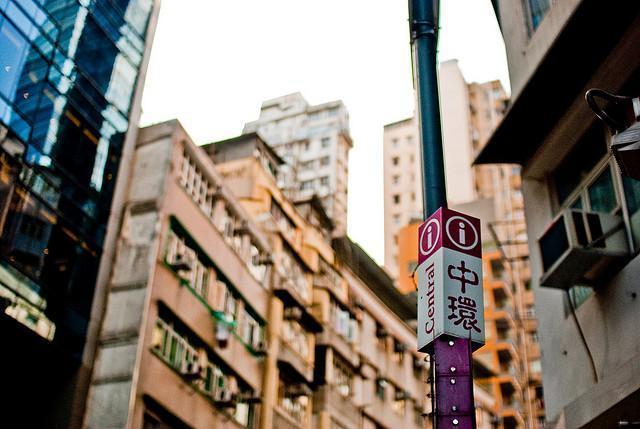How many languages is this sign in?
Give a very brief answer. 2. 